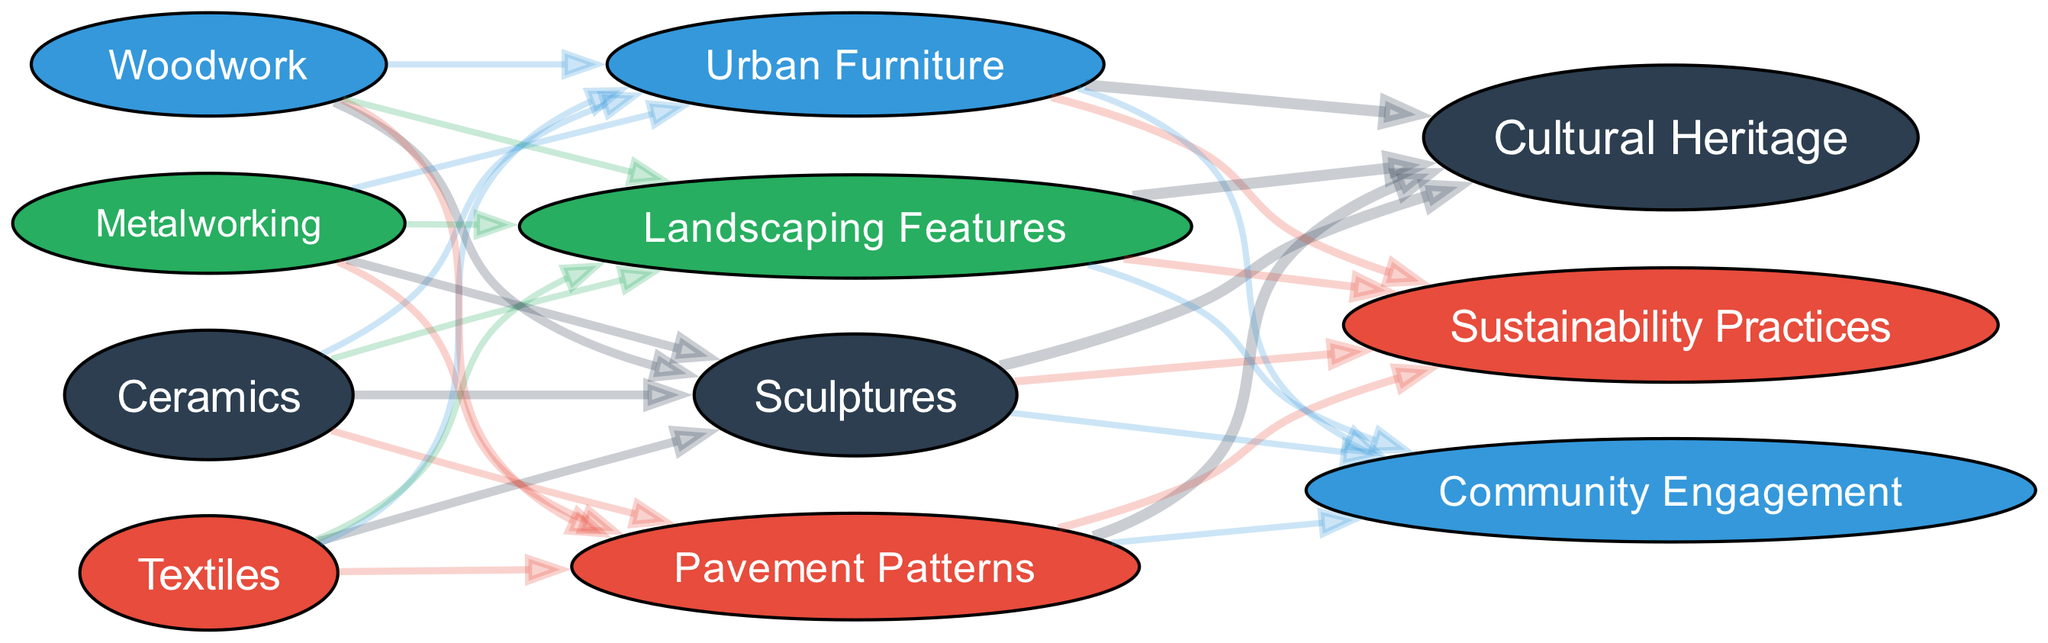What is the total value of "Traditional Craft Techniques"? To find the total value, we sum the values of each technique under "Traditional Craft Techniques": 40 (Ceramics) + 30 (Textiles) + 20 (Woodwork) + 10 (Metalworking) = 100.
Answer: 100 Which design element is influenced the most by traditional craft techniques? By examining the connections from "Traditional Craft Techniques" to "Design Elements in Urban Public Spaces", we see that 35 connects to "Sculptures". This is the highest value among the design elements.
Answer: Sculptures How many influencing factors are represented in the diagram? The diagram lists three influencing factors under the category "Influencing Factors": Cultural Heritage, Sustainability Practices, and Community Engagement, thus making the total count three.
Answer: 3 What percentage of "Cultural Heritage" contributes to the total influence? The value of "Cultural Heritage" is 50. The total influence from all factors (Cultural Heritage + Sustainability Practices + Community Engagement) is 100. The percentage calculation is (50/100) * 100 = 50%.
Answer: 50% Which traditional craft technique contributes least to urban public spaces? The value for "Metalworking" under "Traditional Craft Techniques" is 10, which is the lowest compared to other techniques.
Answer: Metalworking What is the relationship between "Sustainability Practices" and "Landscaping Features"? To analyze this, we check the connections from "Sustainability Practices" to other design elements; however, "Landscaping Features" does not have a direct flow from "Sustainability Practices" as it is not depicted. Therefore, the relationship is nonexistent.
Answer: None What is the total inflow of influence from "Textiles"? The flow of influence from "Textiles" to the design elements shows a total of 30, which directly comes from its sum in the "Traditional Craft Techniques" category.
Answer: 30 Which design element shares the same value with "Urban Furniture"? Exploring the values, we observe that both "Urban Furniture" and "Landscaping Features" have a value of 20, indicating they share the same total influence.
Answer: Landscaping Features What influences the design elements the least? To identify the least influence, we compare the values linked to each design element. "Urban Furniture" and "Landscaping Features" equally hold the value of 20, the lowest among the highest values with others above it but still significant influence.
Answer: 20 